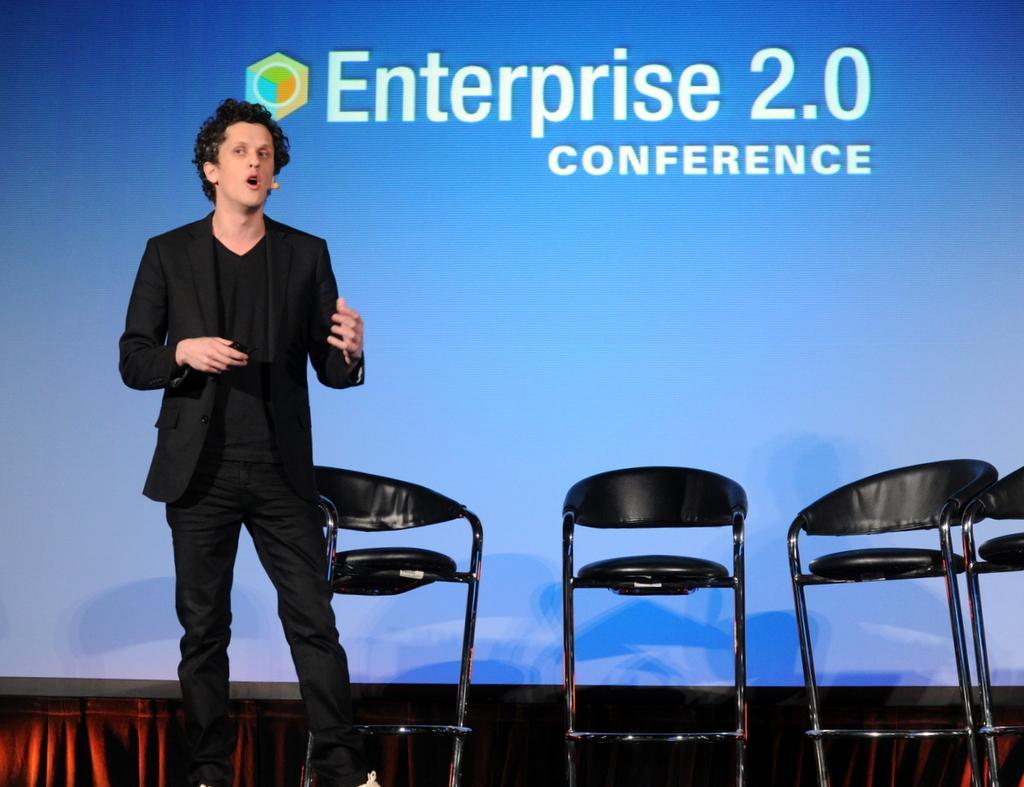How would you summarize this image in a sentence or two? In this picture we an see man wore blazer talking on mic and beside to him there are four chairs and in background we can see screen. 